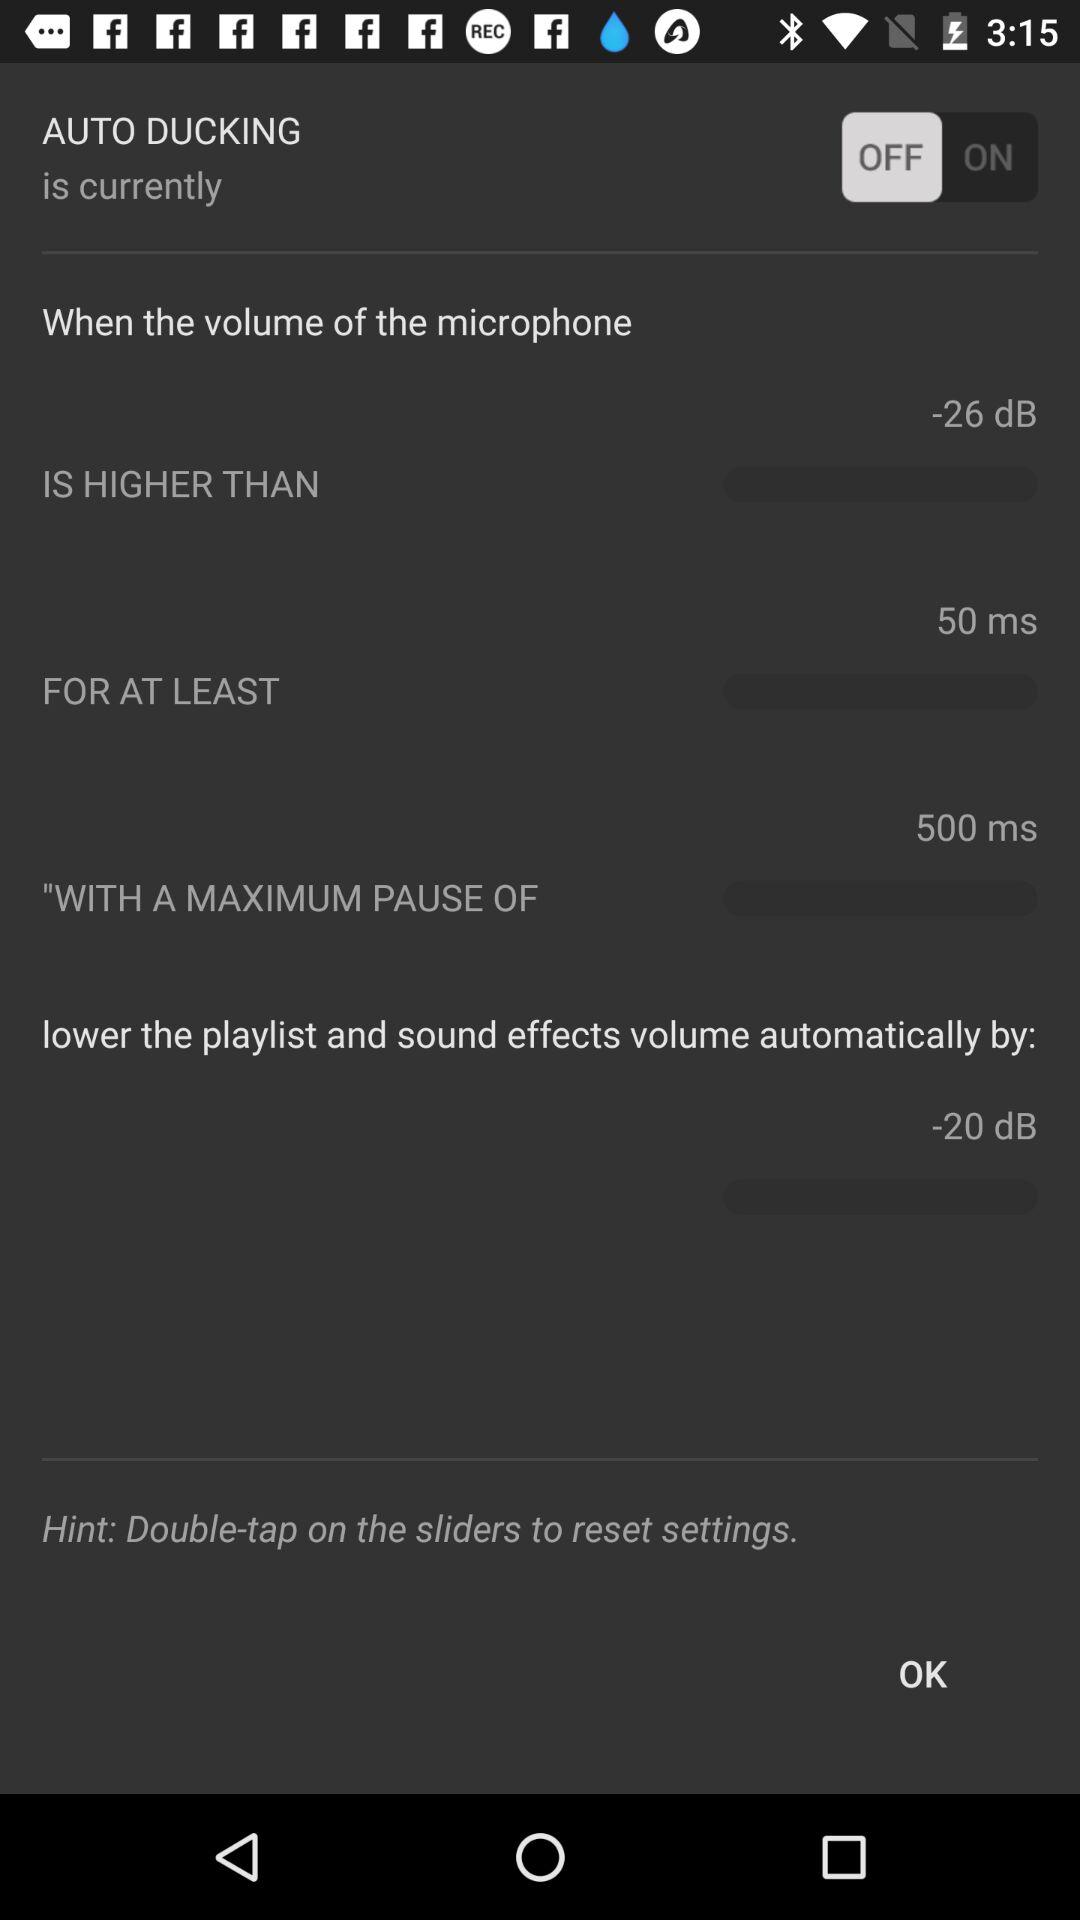Is "OK" selected?
When the provided information is insufficient, respond with <no answer>. <no answer> 